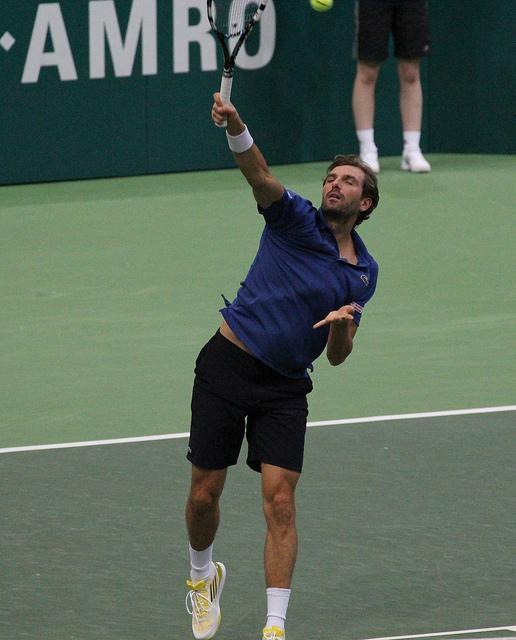How many people can you see?
Give a very brief answer. 2. How many trains are in this photo?
Give a very brief answer. 0. 